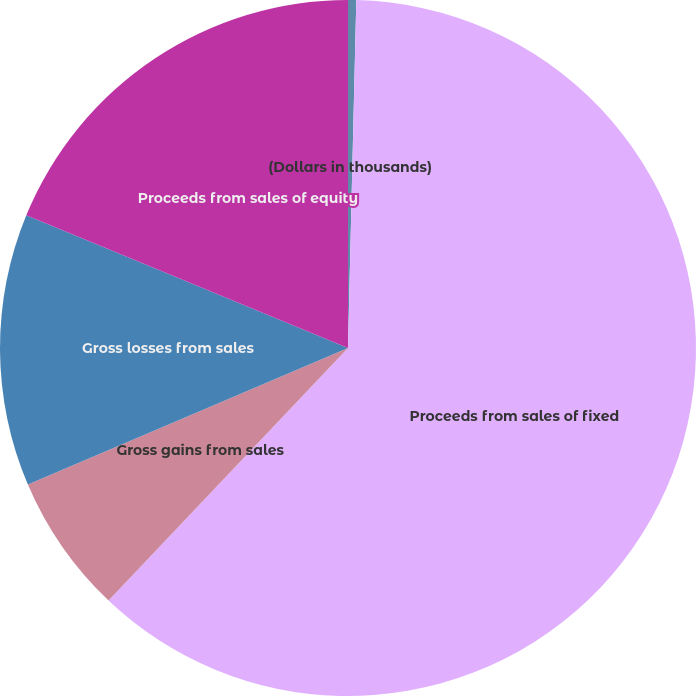Convert chart to OTSL. <chart><loc_0><loc_0><loc_500><loc_500><pie_chart><fcel>(Dollars in thousands)<fcel>Proceeds from sales of fixed<fcel>Gross gains from sales<fcel>Gross losses from sales<fcel>Proceeds from sales of equity<nl><fcel>0.38%<fcel>61.69%<fcel>6.51%<fcel>12.64%<fcel>18.77%<nl></chart> 